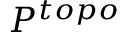Convert formula to latex. <formula><loc_0><loc_0><loc_500><loc_500>P ^ { t o p o }</formula> 